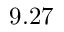Convert formula to latex. <formula><loc_0><loc_0><loc_500><loc_500>9 . 2 7</formula> 